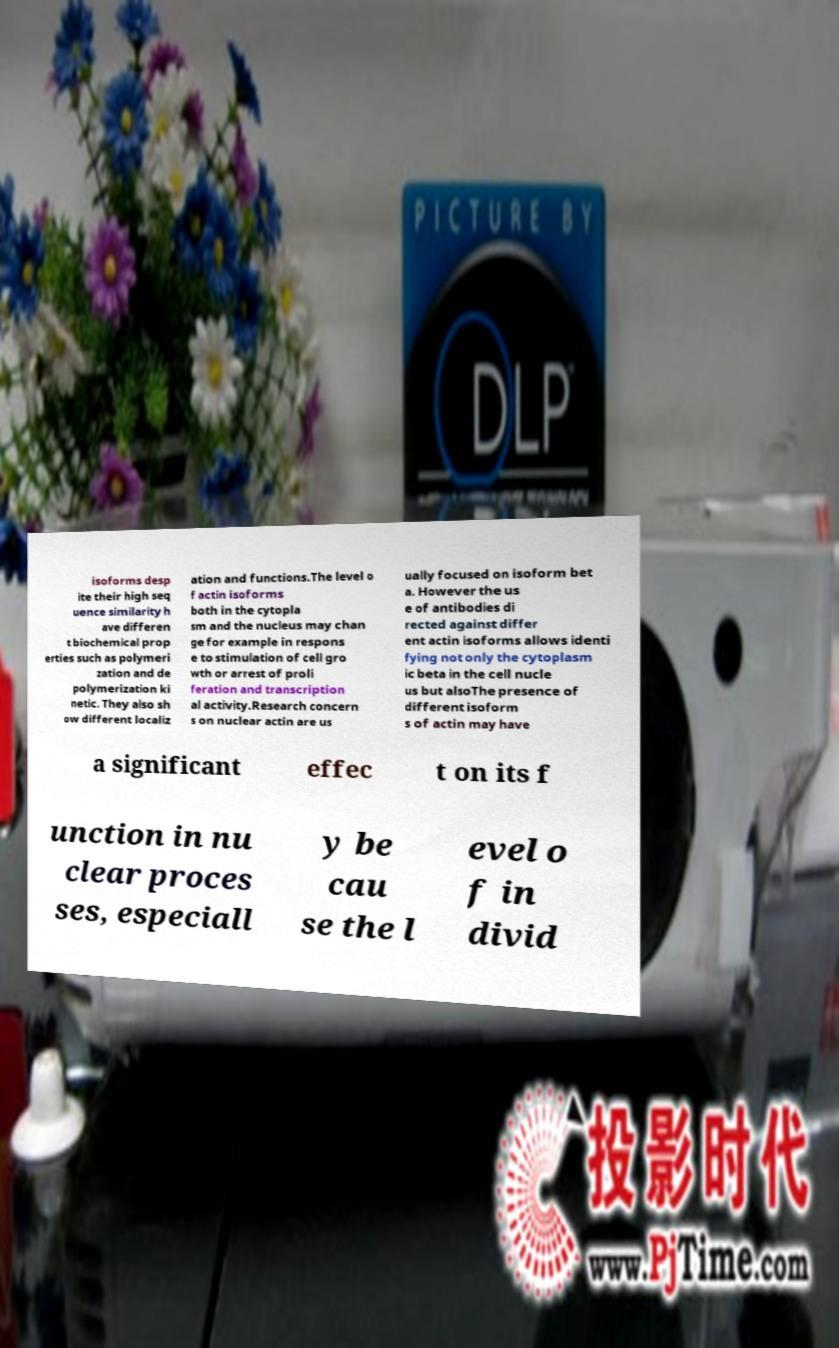Please identify and transcribe the text found in this image. isoforms desp ite their high seq uence similarity h ave differen t biochemical prop erties such as polymeri zation and de polymerization ki netic. They also sh ow different localiz ation and functions.The level o f actin isoforms both in the cytopla sm and the nucleus may chan ge for example in respons e to stimulation of cell gro wth or arrest of proli feration and transcription al activity.Research concern s on nuclear actin are us ually focused on isoform bet a. However the us e of antibodies di rected against differ ent actin isoforms allows identi fying not only the cytoplasm ic beta in the cell nucle us but alsoThe presence of different isoform s of actin may have a significant effec t on its f unction in nu clear proces ses, especiall y be cau se the l evel o f in divid 